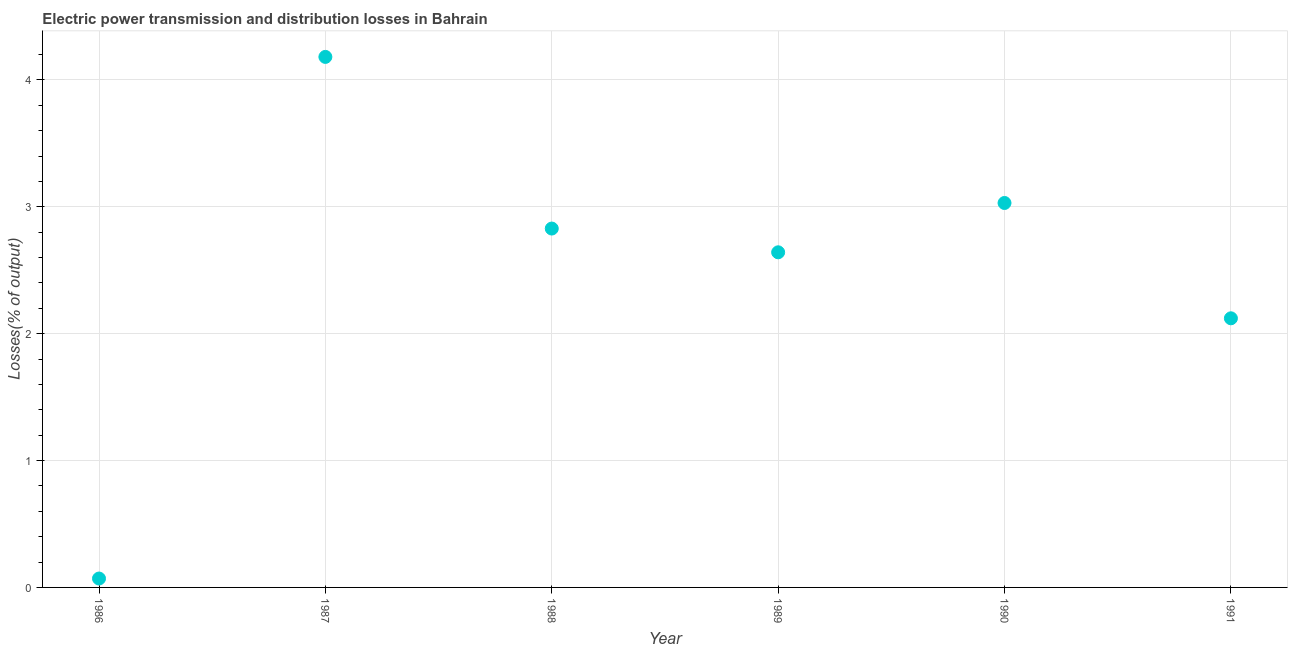What is the electric power transmission and distribution losses in 1990?
Offer a terse response. 3.03. Across all years, what is the maximum electric power transmission and distribution losses?
Provide a short and direct response. 4.18. Across all years, what is the minimum electric power transmission and distribution losses?
Your answer should be compact. 0.07. In which year was the electric power transmission and distribution losses minimum?
Give a very brief answer. 1986. What is the sum of the electric power transmission and distribution losses?
Give a very brief answer. 14.87. What is the difference between the electric power transmission and distribution losses in 1987 and 1988?
Your answer should be compact. 1.35. What is the average electric power transmission and distribution losses per year?
Provide a short and direct response. 2.48. What is the median electric power transmission and distribution losses?
Your answer should be very brief. 2.74. Do a majority of the years between 1986 and 1988 (inclusive) have electric power transmission and distribution losses greater than 0.4 %?
Your answer should be very brief. Yes. What is the ratio of the electric power transmission and distribution losses in 1986 to that in 1988?
Provide a succinct answer. 0.02. Is the difference between the electric power transmission and distribution losses in 1987 and 1988 greater than the difference between any two years?
Ensure brevity in your answer.  No. What is the difference between the highest and the second highest electric power transmission and distribution losses?
Provide a short and direct response. 1.15. Is the sum of the electric power transmission and distribution losses in 1988 and 1990 greater than the maximum electric power transmission and distribution losses across all years?
Provide a short and direct response. Yes. What is the difference between the highest and the lowest electric power transmission and distribution losses?
Provide a short and direct response. 4.11. Does the electric power transmission and distribution losses monotonically increase over the years?
Make the answer very short. No. How many dotlines are there?
Keep it short and to the point. 1. Does the graph contain any zero values?
Provide a succinct answer. No. Does the graph contain grids?
Provide a short and direct response. Yes. What is the title of the graph?
Your response must be concise. Electric power transmission and distribution losses in Bahrain. What is the label or title of the X-axis?
Provide a short and direct response. Year. What is the label or title of the Y-axis?
Make the answer very short. Losses(% of output). What is the Losses(% of output) in 1986?
Make the answer very short. 0.07. What is the Losses(% of output) in 1987?
Your answer should be very brief. 4.18. What is the Losses(% of output) in 1988?
Offer a terse response. 2.83. What is the Losses(% of output) in 1989?
Provide a short and direct response. 2.64. What is the Losses(% of output) in 1990?
Ensure brevity in your answer.  3.03. What is the Losses(% of output) in 1991?
Give a very brief answer. 2.12. What is the difference between the Losses(% of output) in 1986 and 1987?
Give a very brief answer. -4.11. What is the difference between the Losses(% of output) in 1986 and 1988?
Your answer should be very brief. -2.76. What is the difference between the Losses(% of output) in 1986 and 1989?
Provide a succinct answer. -2.57. What is the difference between the Losses(% of output) in 1986 and 1990?
Keep it short and to the point. -2.96. What is the difference between the Losses(% of output) in 1986 and 1991?
Offer a very short reply. -2.05. What is the difference between the Losses(% of output) in 1987 and 1988?
Provide a succinct answer. 1.35. What is the difference between the Losses(% of output) in 1987 and 1989?
Ensure brevity in your answer.  1.54. What is the difference between the Losses(% of output) in 1987 and 1990?
Ensure brevity in your answer.  1.15. What is the difference between the Losses(% of output) in 1987 and 1991?
Keep it short and to the point. 2.06. What is the difference between the Losses(% of output) in 1988 and 1989?
Make the answer very short. 0.19. What is the difference between the Losses(% of output) in 1988 and 1990?
Provide a succinct answer. -0.2. What is the difference between the Losses(% of output) in 1988 and 1991?
Make the answer very short. 0.71. What is the difference between the Losses(% of output) in 1989 and 1990?
Offer a very short reply. -0.39. What is the difference between the Losses(% of output) in 1989 and 1991?
Provide a short and direct response. 0.52. What is the difference between the Losses(% of output) in 1990 and 1991?
Offer a very short reply. 0.91. What is the ratio of the Losses(% of output) in 1986 to that in 1987?
Ensure brevity in your answer.  0.02. What is the ratio of the Losses(% of output) in 1986 to that in 1988?
Your answer should be compact. 0.03. What is the ratio of the Losses(% of output) in 1986 to that in 1989?
Ensure brevity in your answer.  0.03. What is the ratio of the Losses(% of output) in 1986 to that in 1990?
Ensure brevity in your answer.  0.02. What is the ratio of the Losses(% of output) in 1986 to that in 1991?
Give a very brief answer. 0.03. What is the ratio of the Losses(% of output) in 1987 to that in 1988?
Your answer should be compact. 1.48. What is the ratio of the Losses(% of output) in 1987 to that in 1989?
Your answer should be very brief. 1.58. What is the ratio of the Losses(% of output) in 1987 to that in 1990?
Provide a short and direct response. 1.38. What is the ratio of the Losses(% of output) in 1987 to that in 1991?
Give a very brief answer. 1.97. What is the ratio of the Losses(% of output) in 1988 to that in 1989?
Provide a short and direct response. 1.07. What is the ratio of the Losses(% of output) in 1988 to that in 1990?
Provide a succinct answer. 0.93. What is the ratio of the Losses(% of output) in 1988 to that in 1991?
Make the answer very short. 1.33. What is the ratio of the Losses(% of output) in 1989 to that in 1990?
Offer a terse response. 0.87. What is the ratio of the Losses(% of output) in 1989 to that in 1991?
Your answer should be very brief. 1.25. What is the ratio of the Losses(% of output) in 1990 to that in 1991?
Offer a terse response. 1.43. 